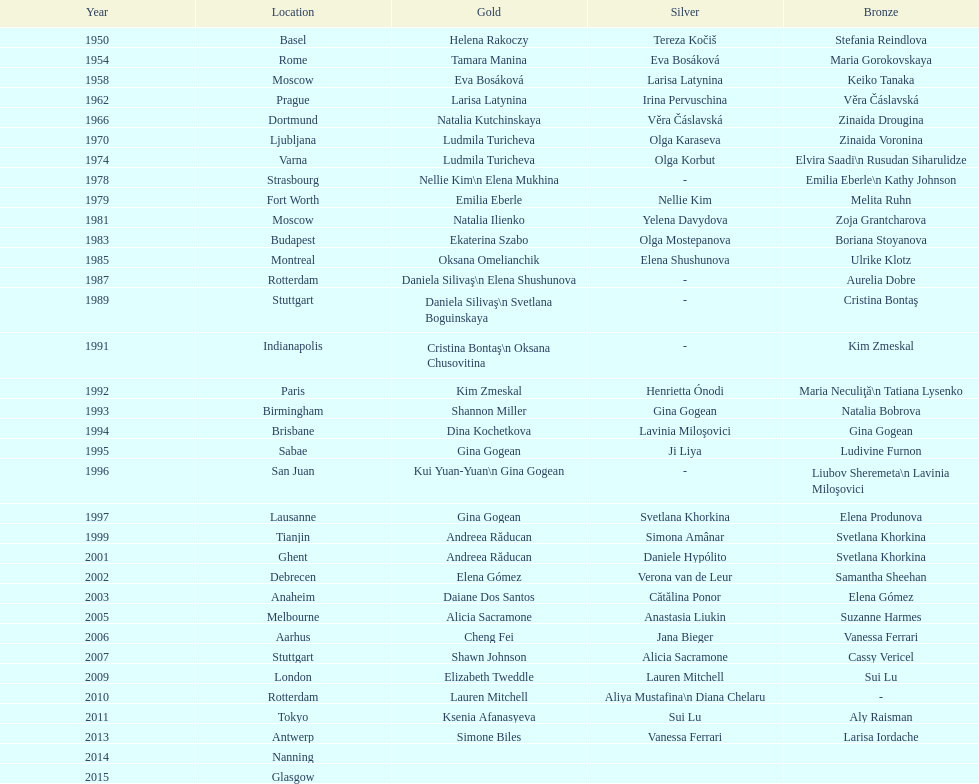Prior to the 1962 prague championships, where were the championships hosted? Moscow. 